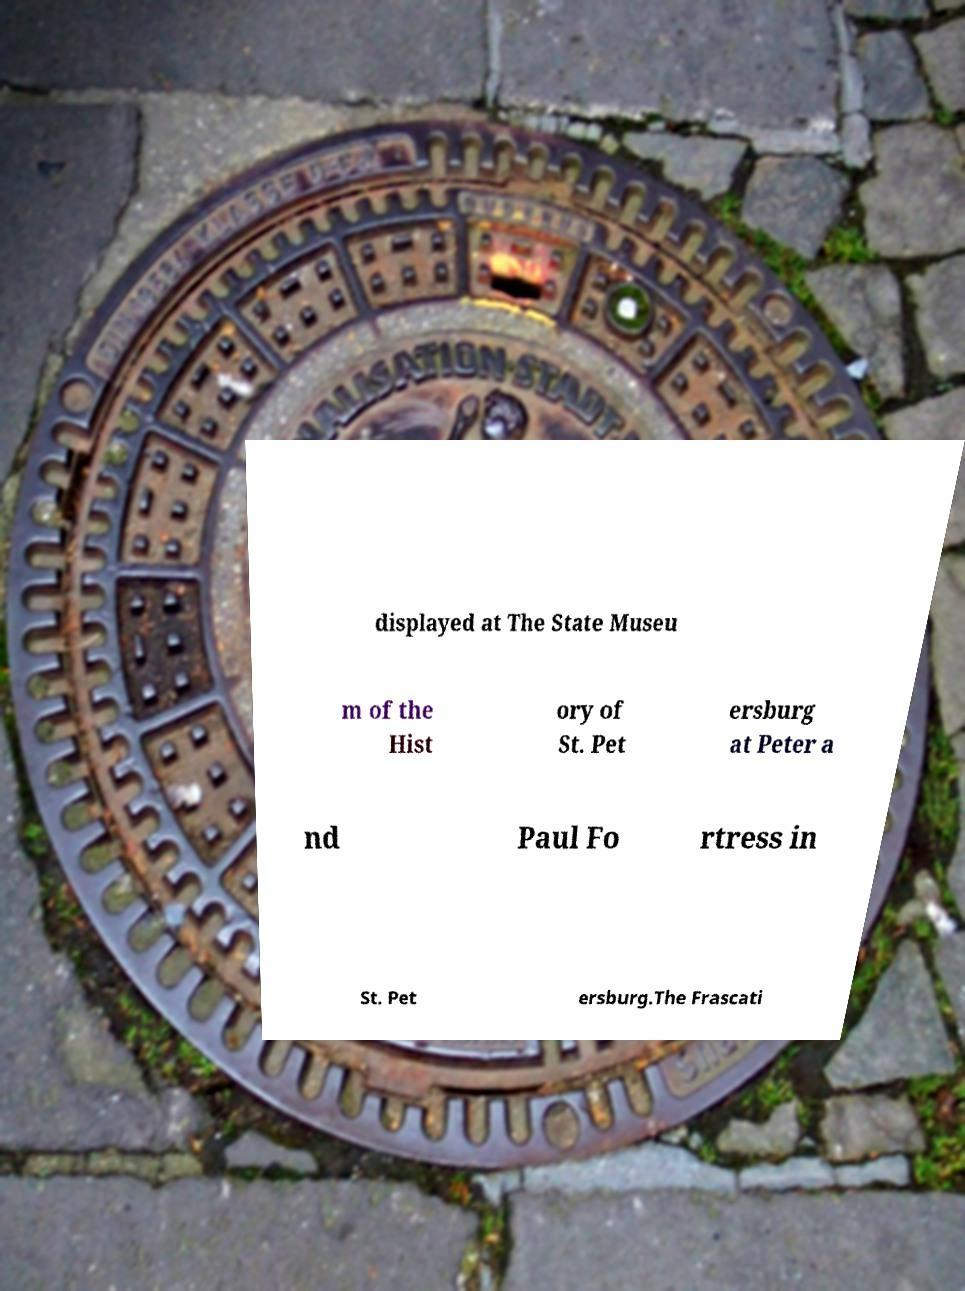What messages or text are displayed in this image? I need them in a readable, typed format. displayed at The State Museu m of the Hist ory of St. Pet ersburg at Peter a nd Paul Fo rtress in St. Pet ersburg.The Frascati 